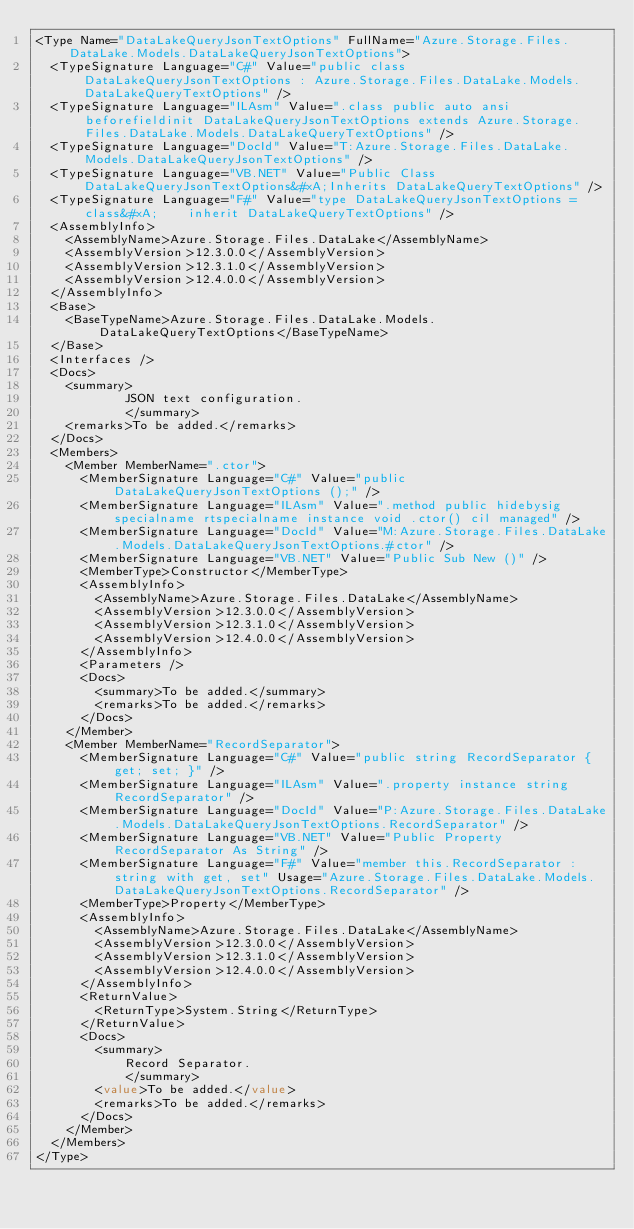<code> <loc_0><loc_0><loc_500><loc_500><_XML_><Type Name="DataLakeQueryJsonTextOptions" FullName="Azure.Storage.Files.DataLake.Models.DataLakeQueryJsonTextOptions">
  <TypeSignature Language="C#" Value="public class DataLakeQueryJsonTextOptions : Azure.Storage.Files.DataLake.Models.DataLakeQueryTextOptions" />
  <TypeSignature Language="ILAsm" Value=".class public auto ansi beforefieldinit DataLakeQueryJsonTextOptions extends Azure.Storage.Files.DataLake.Models.DataLakeQueryTextOptions" />
  <TypeSignature Language="DocId" Value="T:Azure.Storage.Files.DataLake.Models.DataLakeQueryJsonTextOptions" />
  <TypeSignature Language="VB.NET" Value="Public Class DataLakeQueryJsonTextOptions&#xA;Inherits DataLakeQueryTextOptions" />
  <TypeSignature Language="F#" Value="type DataLakeQueryJsonTextOptions = class&#xA;    inherit DataLakeQueryTextOptions" />
  <AssemblyInfo>
    <AssemblyName>Azure.Storage.Files.DataLake</AssemblyName>
    <AssemblyVersion>12.3.0.0</AssemblyVersion>
    <AssemblyVersion>12.3.1.0</AssemblyVersion>
    <AssemblyVersion>12.4.0.0</AssemblyVersion>
  </AssemblyInfo>
  <Base>
    <BaseTypeName>Azure.Storage.Files.DataLake.Models.DataLakeQueryTextOptions</BaseTypeName>
  </Base>
  <Interfaces />
  <Docs>
    <summary>
            JSON text configuration.
            </summary>
    <remarks>To be added.</remarks>
  </Docs>
  <Members>
    <Member MemberName=".ctor">
      <MemberSignature Language="C#" Value="public DataLakeQueryJsonTextOptions ();" />
      <MemberSignature Language="ILAsm" Value=".method public hidebysig specialname rtspecialname instance void .ctor() cil managed" />
      <MemberSignature Language="DocId" Value="M:Azure.Storage.Files.DataLake.Models.DataLakeQueryJsonTextOptions.#ctor" />
      <MemberSignature Language="VB.NET" Value="Public Sub New ()" />
      <MemberType>Constructor</MemberType>
      <AssemblyInfo>
        <AssemblyName>Azure.Storage.Files.DataLake</AssemblyName>
        <AssemblyVersion>12.3.0.0</AssemblyVersion>
        <AssemblyVersion>12.3.1.0</AssemblyVersion>
        <AssemblyVersion>12.4.0.0</AssemblyVersion>
      </AssemblyInfo>
      <Parameters />
      <Docs>
        <summary>To be added.</summary>
        <remarks>To be added.</remarks>
      </Docs>
    </Member>
    <Member MemberName="RecordSeparator">
      <MemberSignature Language="C#" Value="public string RecordSeparator { get; set; }" />
      <MemberSignature Language="ILAsm" Value=".property instance string RecordSeparator" />
      <MemberSignature Language="DocId" Value="P:Azure.Storage.Files.DataLake.Models.DataLakeQueryJsonTextOptions.RecordSeparator" />
      <MemberSignature Language="VB.NET" Value="Public Property RecordSeparator As String" />
      <MemberSignature Language="F#" Value="member this.RecordSeparator : string with get, set" Usage="Azure.Storage.Files.DataLake.Models.DataLakeQueryJsonTextOptions.RecordSeparator" />
      <MemberType>Property</MemberType>
      <AssemblyInfo>
        <AssemblyName>Azure.Storage.Files.DataLake</AssemblyName>
        <AssemblyVersion>12.3.0.0</AssemblyVersion>
        <AssemblyVersion>12.3.1.0</AssemblyVersion>
        <AssemblyVersion>12.4.0.0</AssemblyVersion>
      </AssemblyInfo>
      <ReturnValue>
        <ReturnType>System.String</ReturnType>
      </ReturnValue>
      <Docs>
        <summary>
            Record Separator.
            </summary>
        <value>To be added.</value>
        <remarks>To be added.</remarks>
      </Docs>
    </Member>
  </Members>
</Type>
</code> 